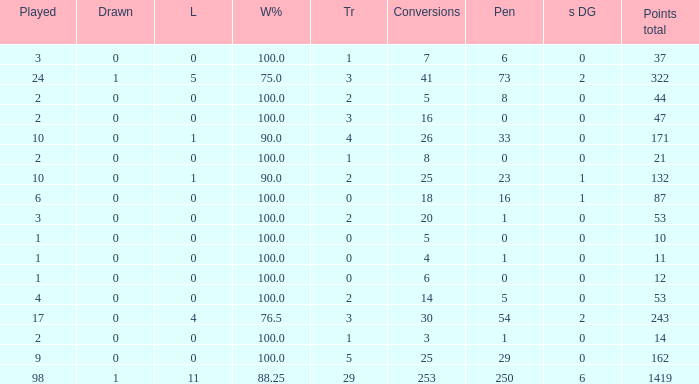How many ties did he have when he had 1 penalties and more than 20 conversions? None. 